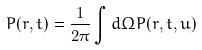Convert formula to latex. <formula><loc_0><loc_0><loc_500><loc_500>P ( r , t ) = \frac { 1 } { 2 \pi } \int d \Omega P ( r , t , u )</formula> 